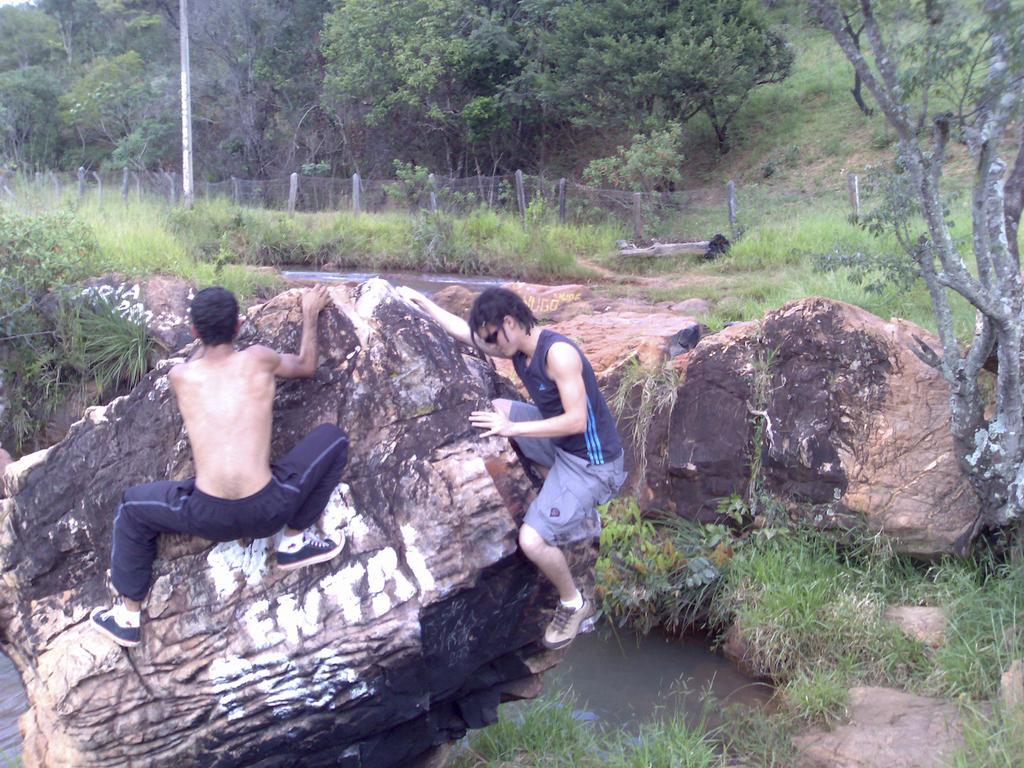Please provide a concise description of this image. In this image I can see two people holding a rock. I can see water,green grass,trees,pole and fencing. 